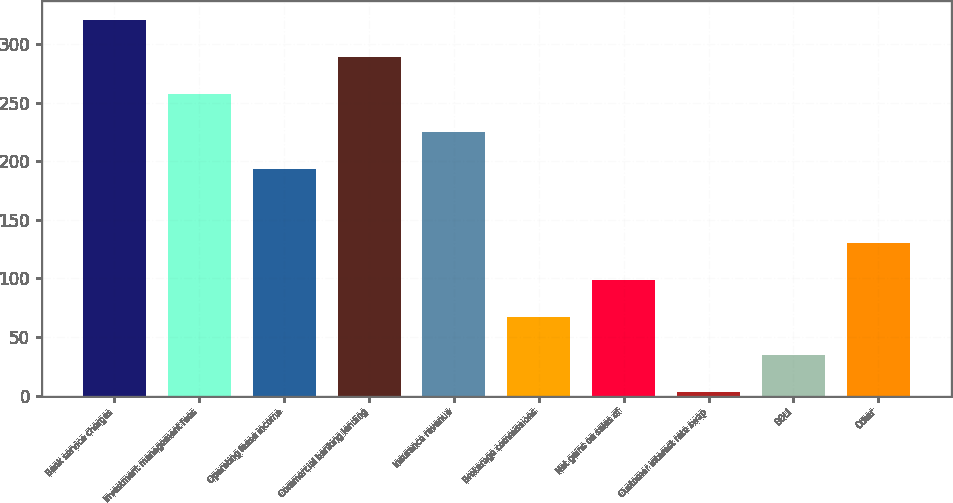Convert chart. <chart><loc_0><loc_0><loc_500><loc_500><bar_chart><fcel>Bank service charges<fcel>Investment management fees<fcel>Operating lease income<fcel>Commercial banking lending<fcel>Insurance revenue<fcel>Brokerage commissions<fcel>Net gains on sales of<fcel>Customer interest rate swap<fcel>BOLI<fcel>Other<nl><fcel>320.4<fcel>257<fcel>193.6<fcel>288.7<fcel>225.3<fcel>66.8<fcel>98.5<fcel>3.4<fcel>35.1<fcel>130.2<nl></chart> 